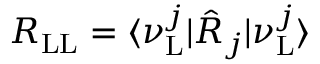<formula> <loc_0><loc_0><loc_500><loc_500>R _ { L L } = \langle \nu _ { L } ^ { j } | \hat { R } _ { j } | \nu _ { L } ^ { j } \rangle</formula> 